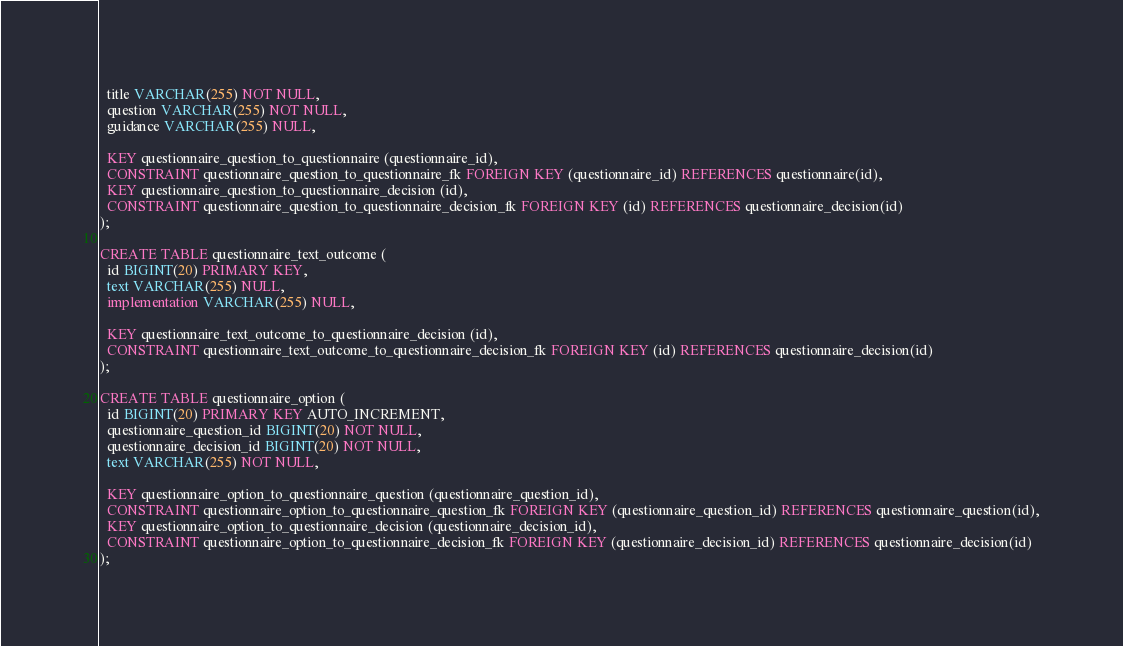<code> <loc_0><loc_0><loc_500><loc_500><_SQL_>  title VARCHAR(255) NOT NULL,
  question VARCHAR(255) NOT NULL,
  guidance VARCHAR(255) NULL,

  KEY questionnaire_question_to_questionnaire (questionnaire_id),
  CONSTRAINT questionnaire_question_to_questionnaire_fk FOREIGN KEY (questionnaire_id) REFERENCES questionnaire(id),
  KEY questionnaire_question_to_questionnaire_decision (id),
  CONSTRAINT questionnaire_question_to_questionnaire_decision_fk FOREIGN KEY (id) REFERENCES questionnaire_decision(id)
);

CREATE TABLE questionnaire_text_outcome (
  id BIGINT(20) PRIMARY KEY,
  text VARCHAR(255) NULL,
  implementation VARCHAR(255) NULL,

  KEY questionnaire_text_outcome_to_questionnaire_decision (id),
  CONSTRAINT questionnaire_text_outcome_to_questionnaire_decision_fk FOREIGN KEY (id) REFERENCES questionnaire_decision(id)
);

CREATE TABLE questionnaire_option (
  id BIGINT(20) PRIMARY KEY AUTO_INCREMENT,
  questionnaire_question_id BIGINT(20) NOT NULL,
  questionnaire_decision_id BIGINT(20) NOT NULL,
  text VARCHAR(255) NOT NULL,

  KEY questionnaire_option_to_questionnaire_question (questionnaire_question_id),
  CONSTRAINT questionnaire_option_to_questionnaire_question_fk FOREIGN KEY (questionnaire_question_id) REFERENCES questionnaire_question(id),
  KEY questionnaire_option_to_questionnaire_decision (questionnaire_decision_id),
  CONSTRAINT questionnaire_option_to_questionnaire_decision_fk FOREIGN KEY (questionnaire_decision_id) REFERENCES questionnaire_decision(id)
);</code> 